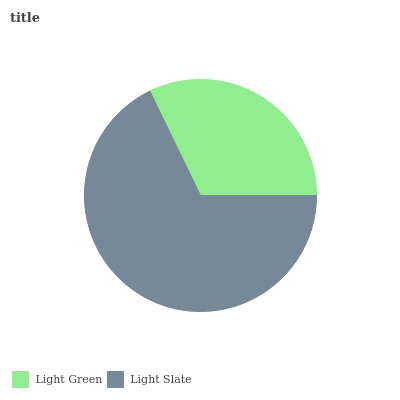Is Light Green the minimum?
Answer yes or no. Yes. Is Light Slate the maximum?
Answer yes or no. Yes. Is Light Slate the minimum?
Answer yes or no. No. Is Light Slate greater than Light Green?
Answer yes or no. Yes. Is Light Green less than Light Slate?
Answer yes or no. Yes. Is Light Green greater than Light Slate?
Answer yes or no. No. Is Light Slate less than Light Green?
Answer yes or no. No. Is Light Slate the high median?
Answer yes or no. Yes. Is Light Green the low median?
Answer yes or no. Yes. Is Light Green the high median?
Answer yes or no. No. Is Light Slate the low median?
Answer yes or no. No. 